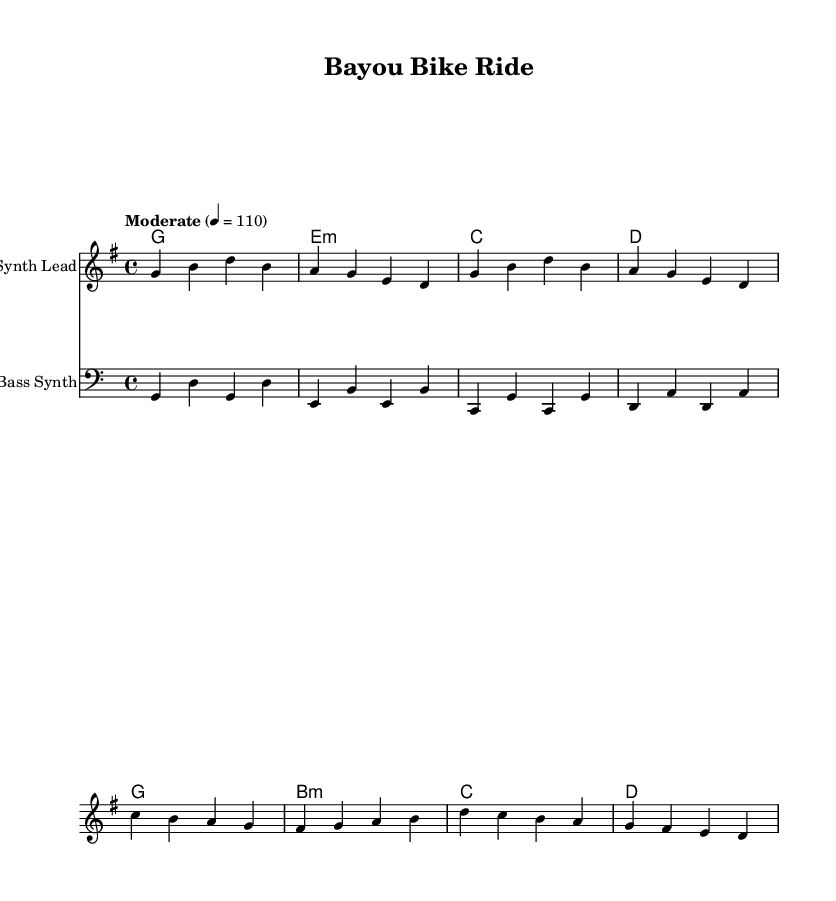What is the key signature of this music? The key signature indicates that the piece is in G major, which has one sharp (F#). This can be identified in the global settings section of the LilyPond code where it states "\key g \major".
Answer: G major What is the time signature of this music? The time signature is established in the global settings section. It is denoted as "\time 4/4", meaning there are four beats per measure.
Answer: 4/4 What is the tempo marking of this music? The tempo marking is specified by the directive "\tempo "Moderate" 4 = 110" in the global settings. It indicates a moderate speed at 110 beats per minute.
Answer: 110 Which instrument is identified as playing the "Synth Lead"? In the score section, the instrument for the staff that plays the melody is labeled as "Synth Lead". This is specified within the "\new Staff \with { instrumentName = "Synth Lead" }" directive.
Answer: Synth Lead What type of chord is listed in the second measure of harmonies? The chord in the second measure is identified as E minor, which is indicated by "e:m" in the harmonies section. This minor chord is represented in standard chord notation.
Answer: E minor What is the final chord in the harmonies section? The final chord is represented in the last measure of the harmonies section and is labeled "d" which stands for D major chord. This notation indicates the last chord to be played in the progression.
Answer: D major 